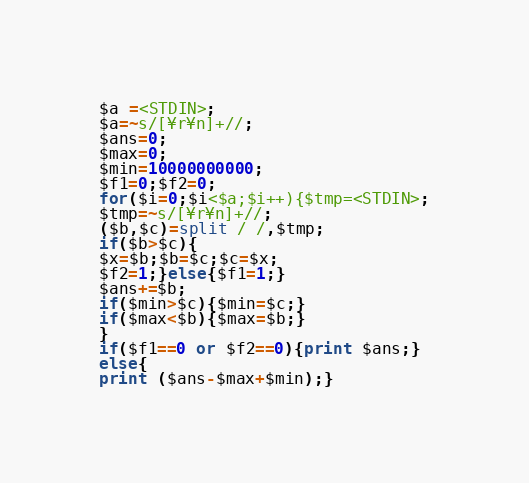Convert code to text. <code><loc_0><loc_0><loc_500><loc_500><_Perl_>$a =<STDIN>;
$a=~s/[¥r¥n]+//;
$ans=0;
$max=0;
$min=10000000000;
$f1=0;$f2=0;
for($i=0;$i<$a;$i++){$tmp=<STDIN>;
$tmp=~s/[¥r¥n]+//;
($b,$c)=split / /,$tmp;
if($b>$c){
$x=$b;$b=$c;$c=$x;
$f2=1;}else{$f1=1;}
$ans+=$b;
if($min>$c){$min=$c;}
if($max<$b){$max=$b;}
}
if($f1==0 or $f2==0){print $ans;}
else{
print ($ans-$max+$min);}
</code> 